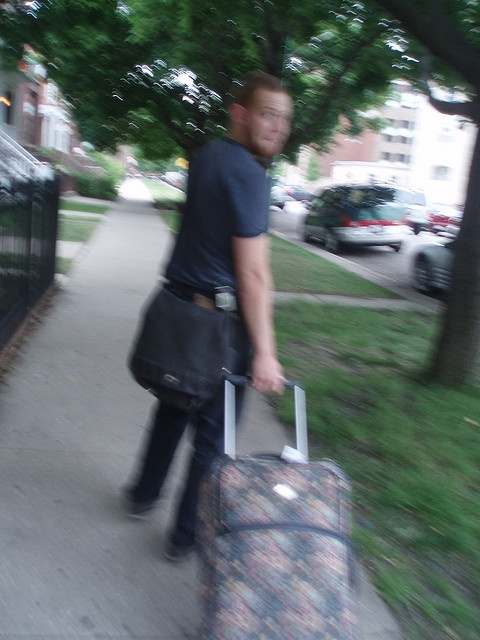Describe the objects in this image and their specific colors. I can see people in black, gray, navy, and darkgray tones, suitcase in black, darkgray, and gray tones, handbag in black and gray tones, backpack in black and gray tones, and car in black, gray, blue, and lavender tones in this image. 